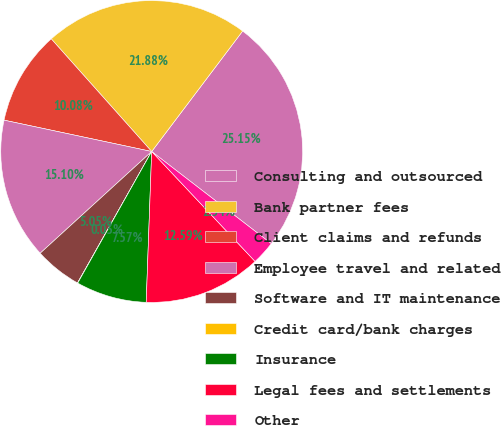Convert chart to OTSL. <chart><loc_0><loc_0><loc_500><loc_500><pie_chart><fcel>Consulting and outsourced<fcel>Bank partner fees<fcel>Client claims and refunds<fcel>Employee travel and related<fcel>Software and IT maintenance<fcel>Credit card/bank charges<fcel>Insurance<fcel>Legal fees and settlements<fcel>Other<nl><fcel>25.15%<fcel>21.88%<fcel>10.08%<fcel>15.1%<fcel>5.05%<fcel>0.03%<fcel>7.57%<fcel>12.59%<fcel>2.54%<nl></chart> 